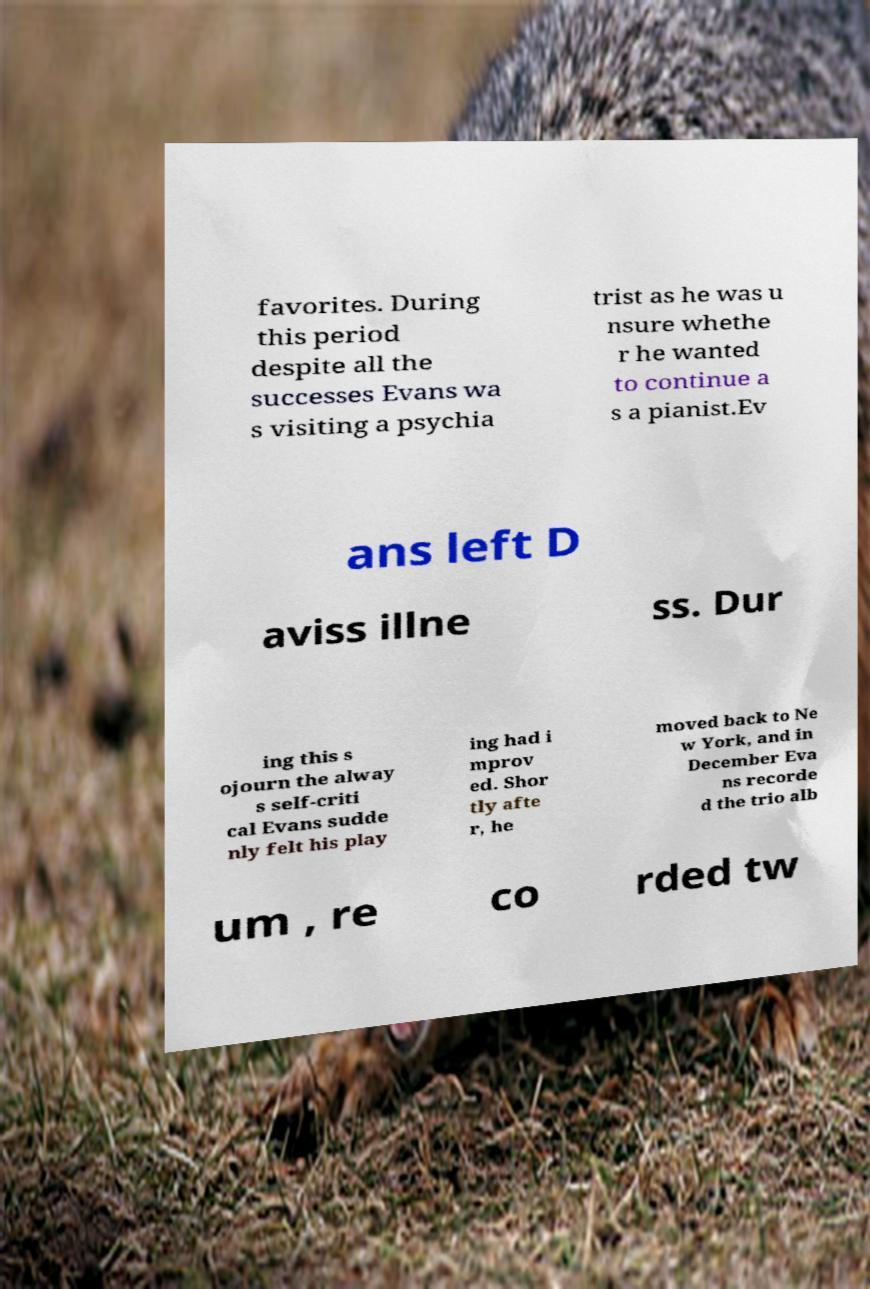Can you accurately transcribe the text from the provided image for me? favorites. During this period despite all the successes Evans wa s visiting a psychia trist as he was u nsure whethe r he wanted to continue a s a pianist.Ev ans left D aviss illne ss. Dur ing this s ojourn the alway s self-criti cal Evans sudde nly felt his play ing had i mprov ed. Shor tly afte r, he moved back to Ne w York, and in December Eva ns recorde d the trio alb um , re co rded tw 